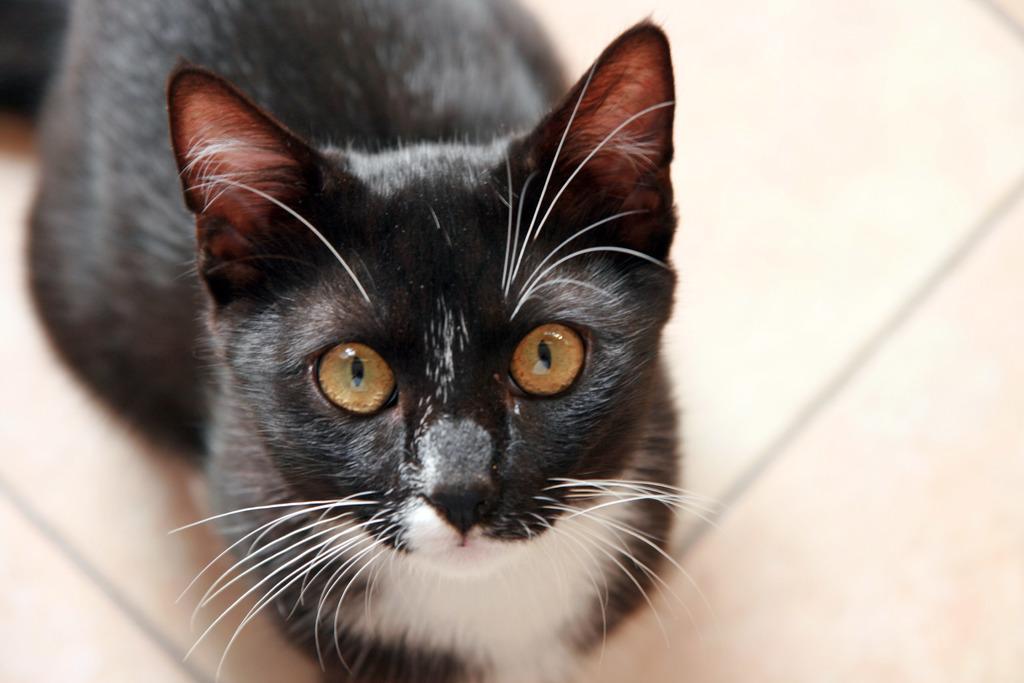Could you give a brief overview of what you see in this image? It is a black color cat looking at this side. 